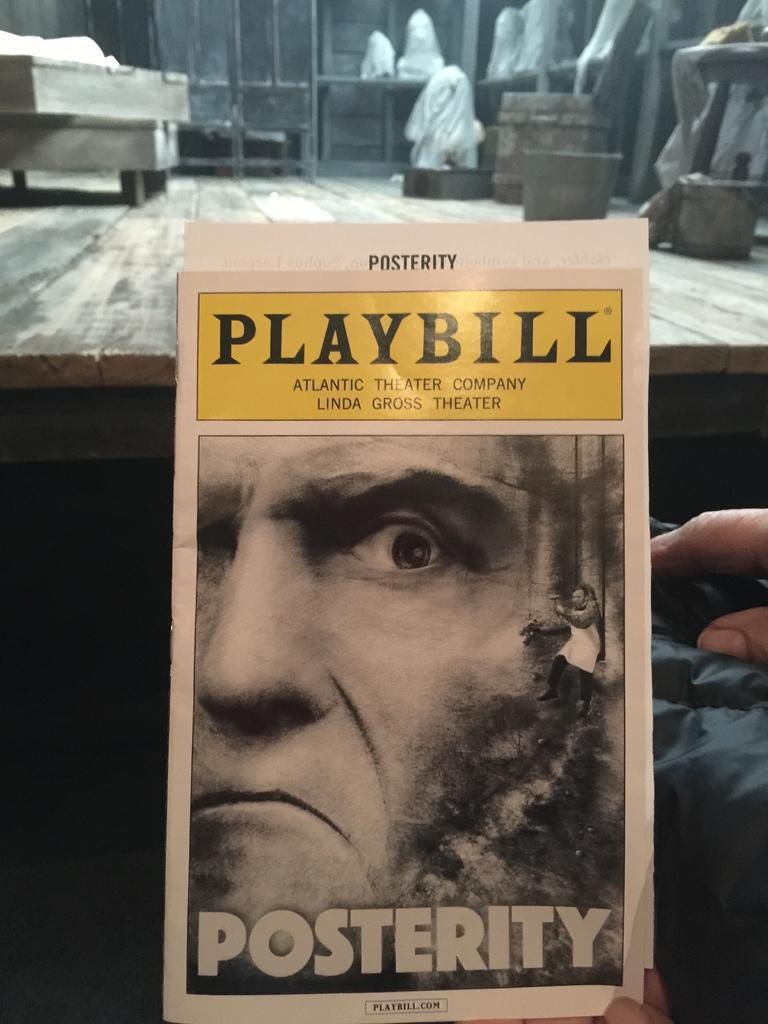In one or two sentences, can you explain what this image depicts? In the image there is a poster of a man in front of a table and there are few buckets on the table. 